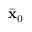Convert formula to latex. <formula><loc_0><loc_0><loc_500><loc_500>\bar { x } _ { 0 }</formula> 